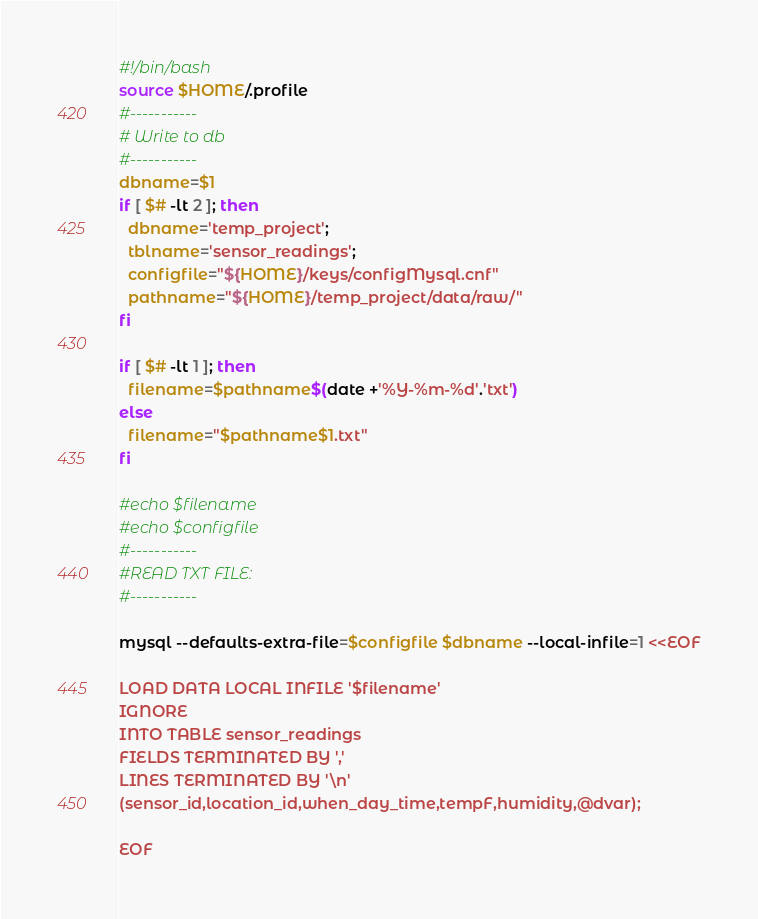Convert code to text. <code><loc_0><loc_0><loc_500><loc_500><_Bash_>#!/bin/bash
source $HOME/.profile
#-----------
# Write to db
#-----------
dbname=$1
if [ $# -lt 2 ]; then
  dbname='temp_project';
  tblname='sensor_readings';
  configfile="${HOME}/keys/configMysql.cnf"
  pathname="${HOME}/temp_project/data/raw/"
fi

if [ $# -lt 1 ]; then
  filename=$pathname$(date +'%Y-%m-%d'.'txt')
else
  filename="$pathname$1.txt"
fi

#echo $filename
#echo $configfile
#-----------
#READ TXT FILE:
#-----------

mysql --defaults-extra-file=$configfile $dbname --local-infile=1 <<EOF

LOAD DATA LOCAL INFILE '$filename'
IGNORE
INTO TABLE sensor_readings 
FIELDS TERMINATED BY ',' 
LINES TERMINATED BY '\n' 
(sensor_id,location_id,when_day_time,tempF,humidity,@dvar);

EOF


</code> 